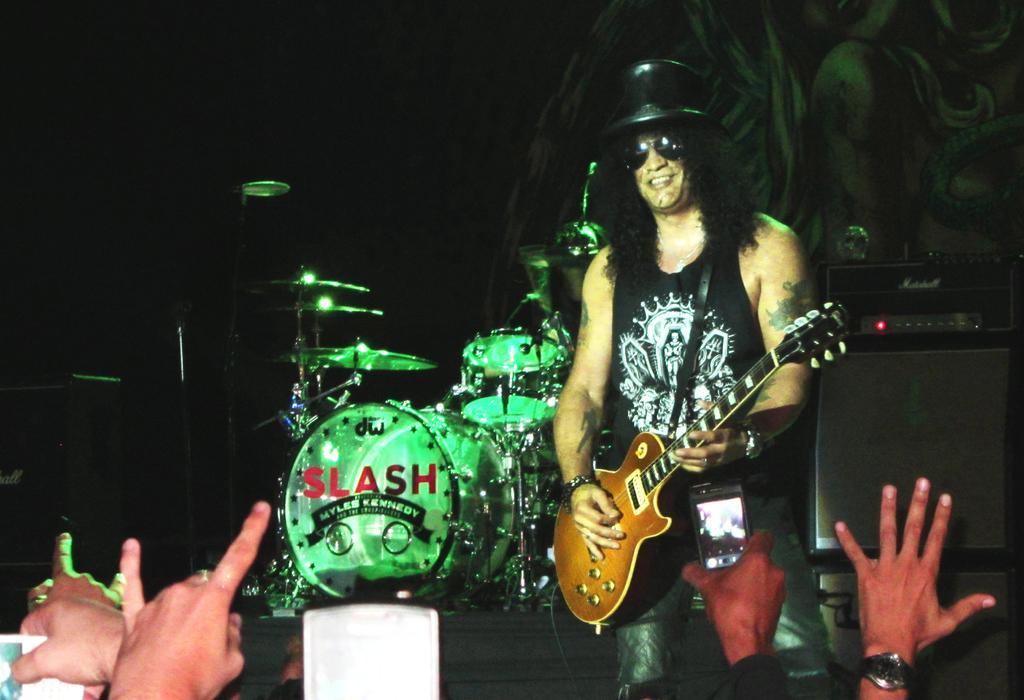How would you summarize this image in a sentence or two? In this image there is a man standing and playing guitar , and the background there are drums and persons. 